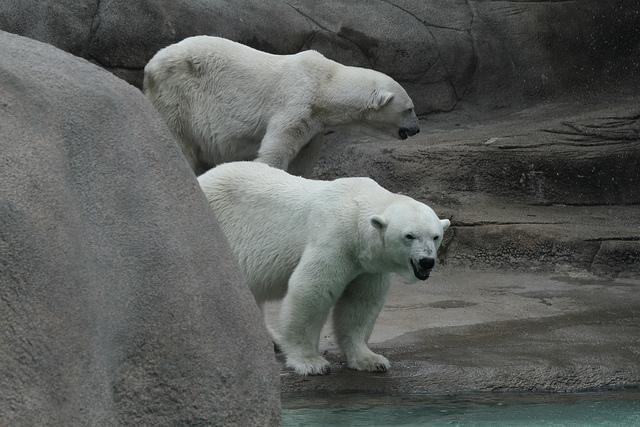How many polar bears are there?
Give a very brief answer. 2. How many bears can be seen?
Give a very brief answer. 2. 